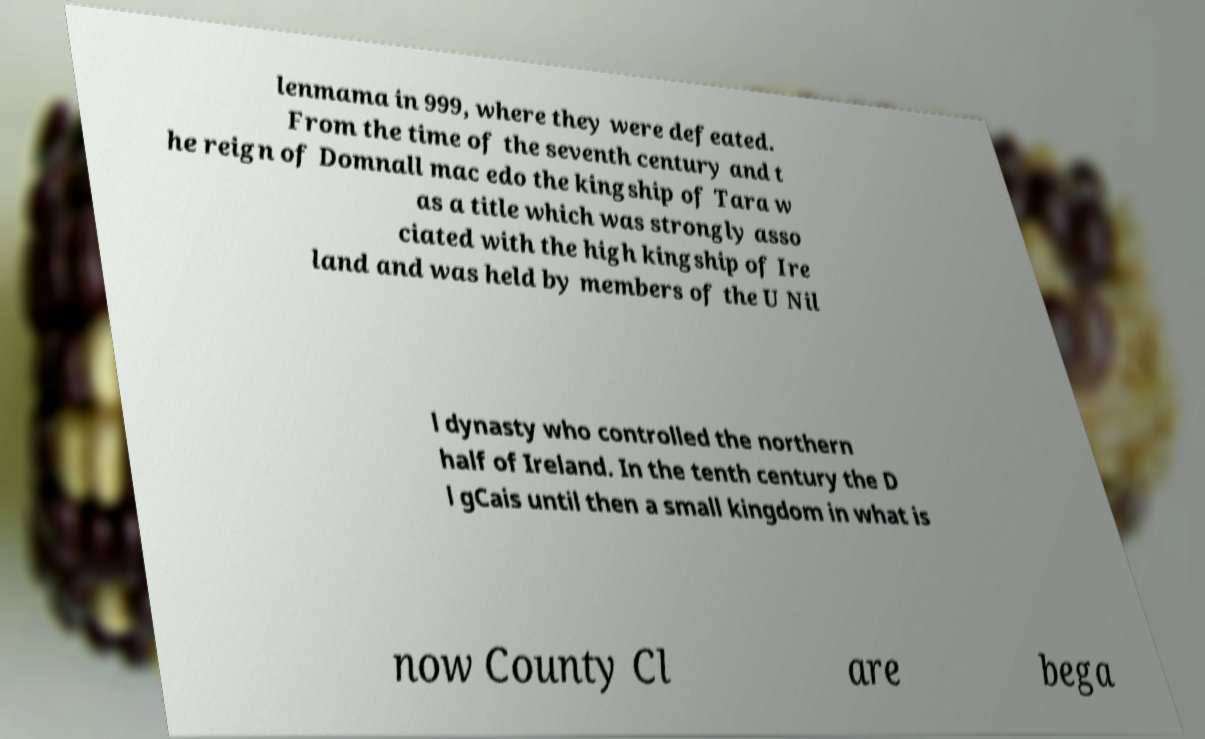Can you accurately transcribe the text from the provided image for me? lenmama in 999, where they were defeated. From the time of the seventh century and t he reign of Domnall mac edo the kingship of Tara w as a title which was strongly asso ciated with the high kingship of Ire land and was held by members of the U Nil l dynasty who controlled the northern half of Ireland. In the tenth century the D l gCais until then a small kingdom in what is now County Cl are bega 